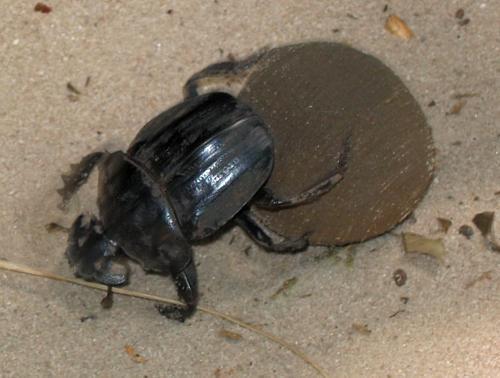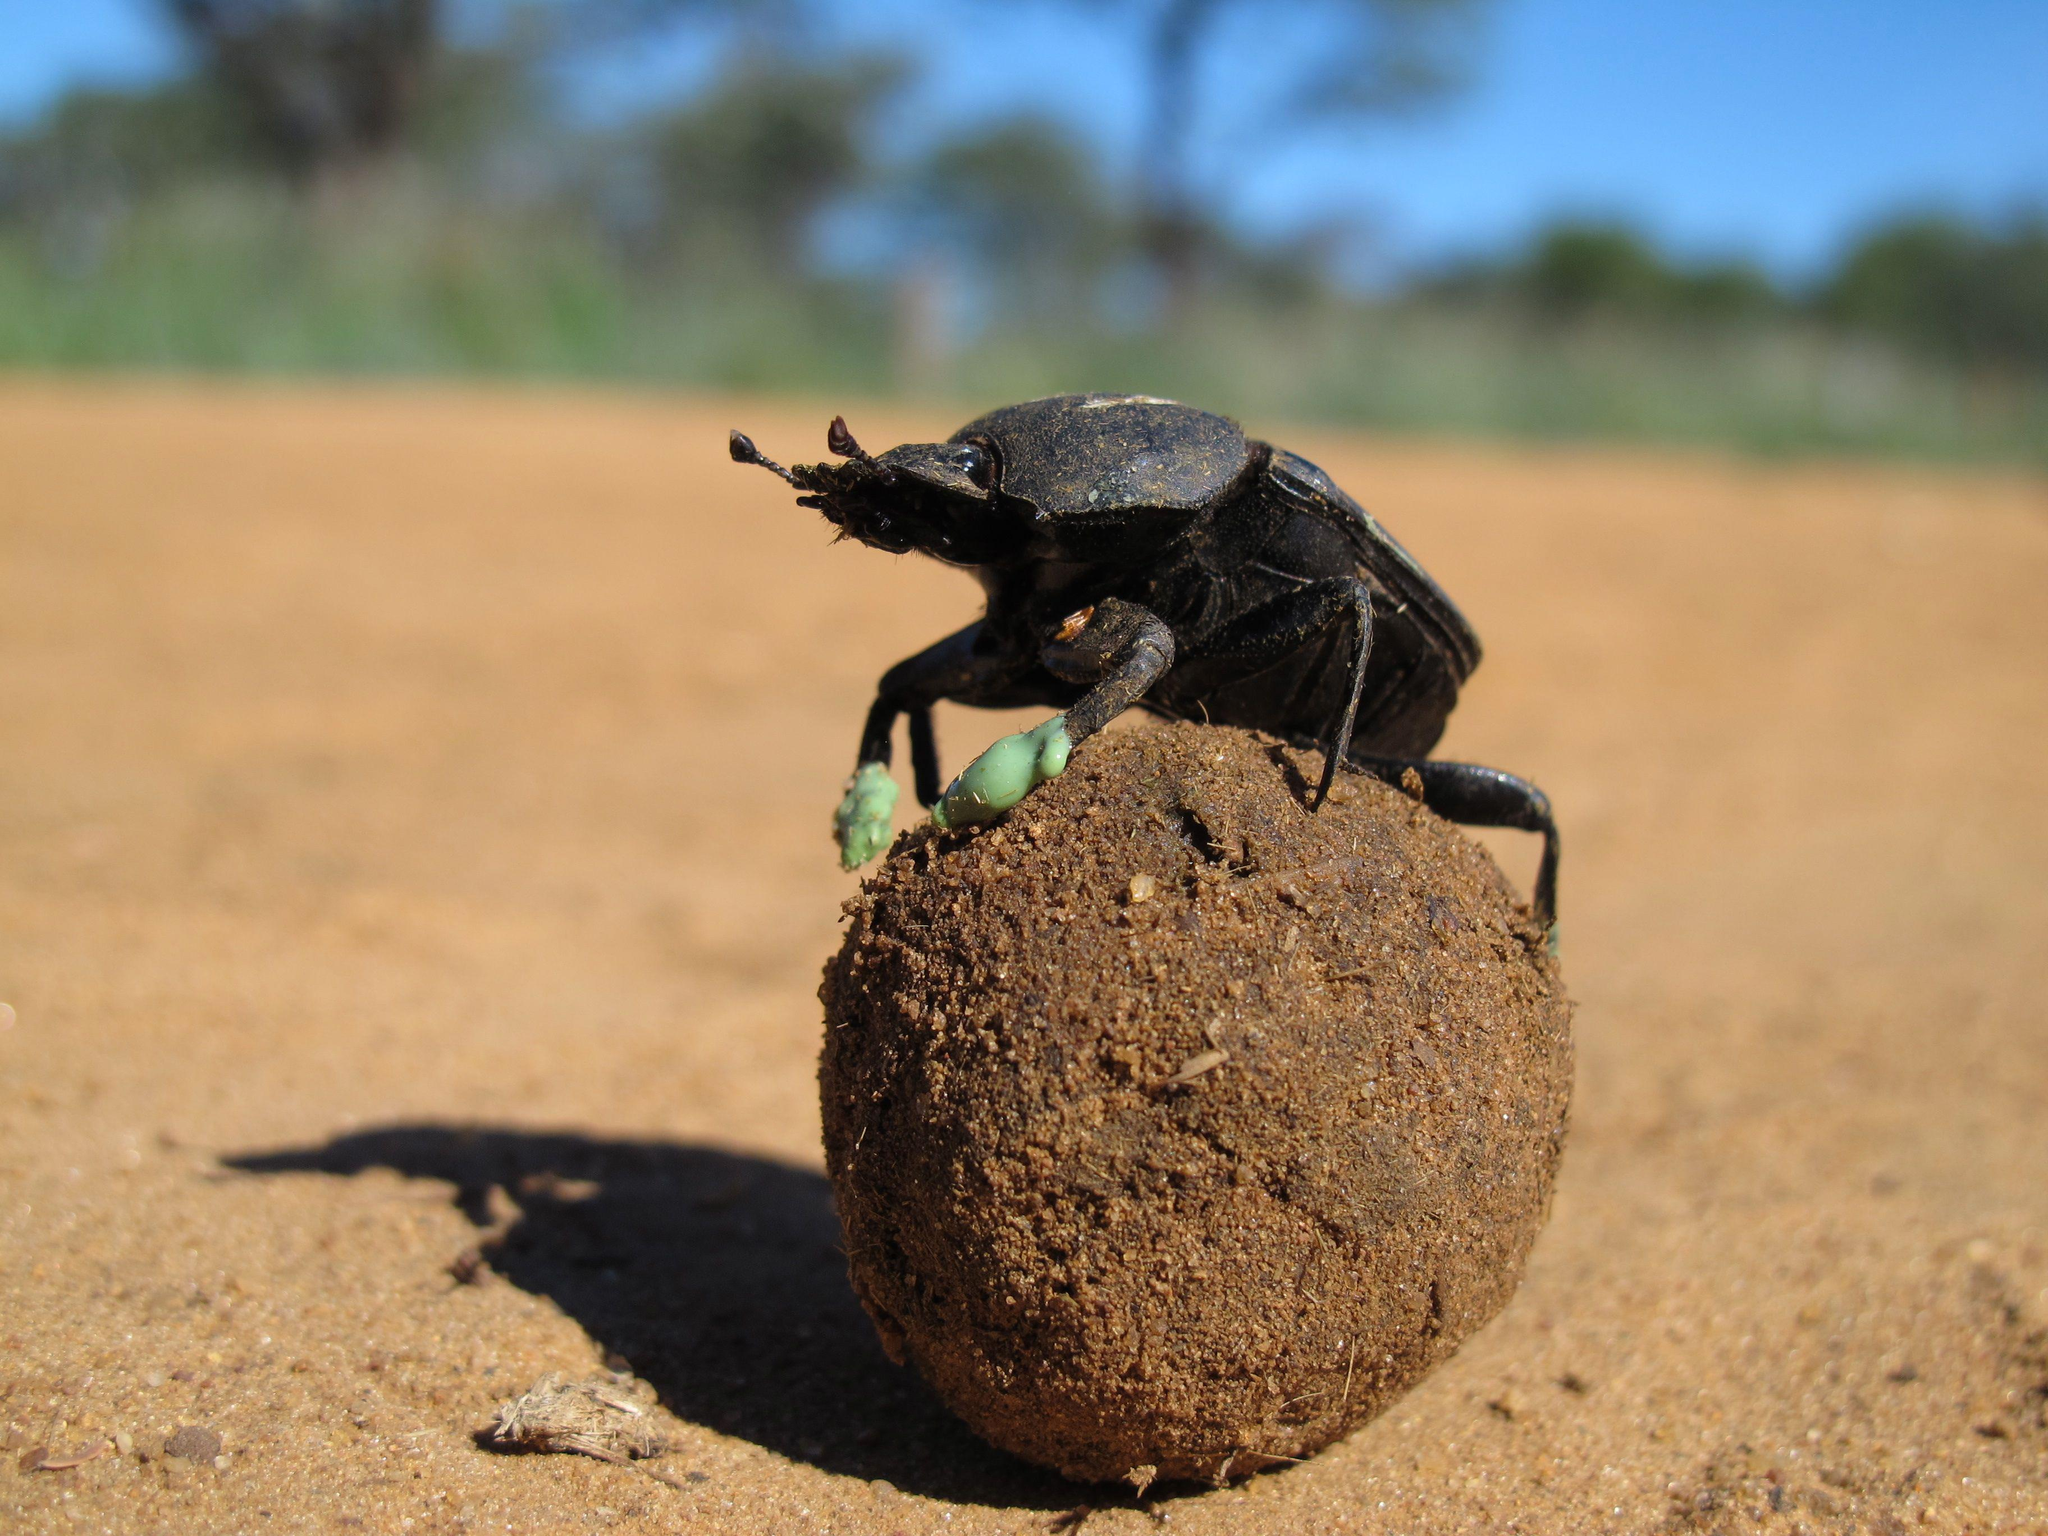The first image is the image on the left, the second image is the image on the right. Considering the images on both sides, is "There is no dung in one image." valid? Answer yes or no. No. The first image is the image on the left, the second image is the image on the right. Analyze the images presented: Is the assertion "Each image shows exactly one dark beetle in contact with one brown ball." valid? Answer yes or no. Yes. 